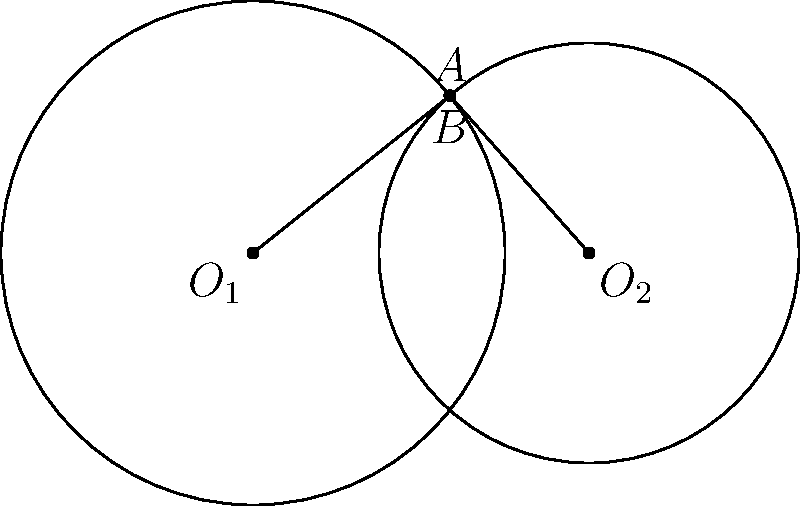In the diagram, two circles intersect, forming a shape reminiscent of overlapping territories in shogi. Circle $O_1$ has radius 3 units, and circle $O_2$ has radius 2.5 units. The centers of the circles are 4 units apart. If point $A$ is one of the intersection points of the circles, and $B$ is the reflection of $A$ across line $O_1O_2$, what is the length of line segment $AB$? Let's approach this step-by-step:

1) First, we need to find the coordinates of point $A$. We can do this using the equations of the two circles:

   Circle $O_1$: $x^2 + y^2 = 9$
   Circle $O_2$: $(x-4)^2 + y^2 = 6.25$

2) Solving these equations simultaneously:

   $x^2 + y^2 = 9$
   $x^2 - 8x + 16 + y^2 = 6.25$

3) Subtracting the first equation from the second:

   $-8x + 16 = -2.75$
   $8x = 18.75$
   $x = 2.34375$

4) Substituting this back into the equation of the first circle:

   $(2.34375)^2 + y^2 = 9$
   $y^2 = 3.5078125$
   $y = \pm 1.8728$

5) So, the coordinates of $A$ are approximately $(2.34375, 1.8728)$

6) Point $B$ is the reflection of $A$ across the $x$-axis, so its coordinates are $(2.34375, -1.8728)$

7) The length of $AB$ is the distance between these two points:

   $AB = \sqrt{(2.34375 - 2.34375)^2 + (1.8728 - (-1.8728))^2}$
       $= \sqrt{0^2 + (3.7456)^2}$
       $= 3.7456$

Therefore, the length of line segment $AB$ is approximately 3.7456 units.
Answer: 3.7456 units 